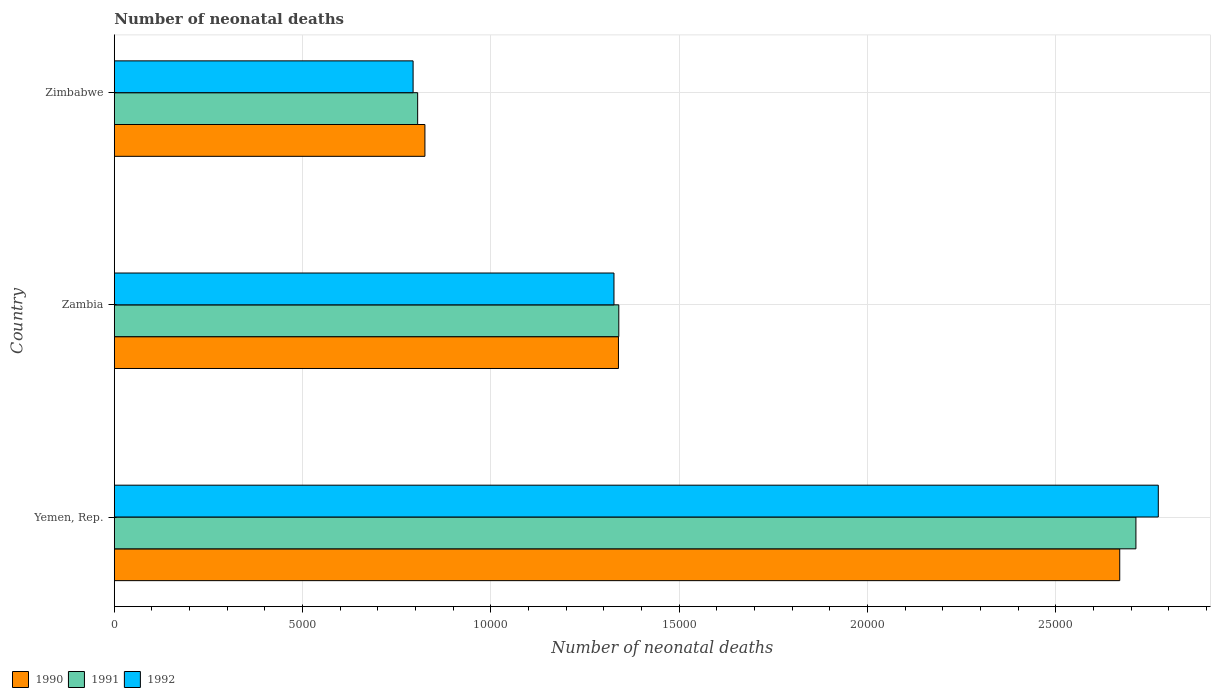How many different coloured bars are there?
Ensure brevity in your answer.  3. How many bars are there on the 1st tick from the top?
Give a very brief answer. 3. How many bars are there on the 3rd tick from the bottom?
Make the answer very short. 3. What is the label of the 2nd group of bars from the top?
Your response must be concise. Zambia. What is the number of neonatal deaths in in 1990 in Zambia?
Offer a very short reply. 1.34e+04. Across all countries, what is the maximum number of neonatal deaths in in 1990?
Make the answer very short. 2.67e+04. Across all countries, what is the minimum number of neonatal deaths in in 1990?
Offer a terse response. 8248. In which country was the number of neonatal deaths in in 1991 maximum?
Ensure brevity in your answer.  Yemen, Rep. In which country was the number of neonatal deaths in in 1992 minimum?
Ensure brevity in your answer.  Zimbabwe. What is the total number of neonatal deaths in in 1992 in the graph?
Your answer should be very brief. 4.89e+04. What is the difference between the number of neonatal deaths in in 1992 in Yemen, Rep. and that in Zambia?
Your answer should be very brief. 1.45e+04. What is the difference between the number of neonatal deaths in in 1992 in Yemen, Rep. and the number of neonatal deaths in in 1991 in Zimbabwe?
Provide a short and direct response. 1.97e+04. What is the average number of neonatal deaths in in 1990 per country?
Provide a succinct answer. 1.61e+04. What is the difference between the number of neonatal deaths in in 1991 and number of neonatal deaths in in 1990 in Zambia?
Give a very brief answer. 9. What is the ratio of the number of neonatal deaths in in 1990 in Zambia to that in Zimbabwe?
Offer a very short reply. 1.62. Is the difference between the number of neonatal deaths in in 1991 in Yemen, Rep. and Zimbabwe greater than the difference between the number of neonatal deaths in in 1990 in Yemen, Rep. and Zimbabwe?
Your answer should be compact. Yes. What is the difference between the highest and the second highest number of neonatal deaths in in 1991?
Your response must be concise. 1.37e+04. What is the difference between the highest and the lowest number of neonatal deaths in in 1992?
Keep it short and to the point. 1.98e+04. In how many countries, is the number of neonatal deaths in in 1990 greater than the average number of neonatal deaths in in 1990 taken over all countries?
Offer a terse response. 1. Is the sum of the number of neonatal deaths in in 1991 in Yemen, Rep. and Zimbabwe greater than the maximum number of neonatal deaths in in 1990 across all countries?
Provide a succinct answer. Yes. Is it the case that in every country, the sum of the number of neonatal deaths in in 1991 and number of neonatal deaths in in 1992 is greater than the number of neonatal deaths in in 1990?
Give a very brief answer. Yes. What is the difference between two consecutive major ticks on the X-axis?
Ensure brevity in your answer.  5000. Are the values on the major ticks of X-axis written in scientific E-notation?
Make the answer very short. No. What is the title of the graph?
Your answer should be compact. Number of neonatal deaths. What is the label or title of the X-axis?
Your response must be concise. Number of neonatal deaths. What is the label or title of the Y-axis?
Give a very brief answer. Country. What is the Number of neonatal deaths of 1990 in Yemen, Rep.?
Ensure brevity in your answer.  2.67e+04. What is the Number of neonatal deaths of 1991 in Yemen, Rep.?
Keep it short and to the point. 2.71e+04. What is the Number of neonatal deaths in 1992 in Yemen, Rep.?
Provide a short and direct response. 2.77e+04. What is the Number of neonatal deaths in 1990 in Zambia?
Provide a succinct answer. 1.34e+04. What is the Number of neonatal deaths of 1991 in Zambia?
Ensure brevity in your answer.  1.34e+04. What is the Number of neonatal deaths of 1992 in Zambia?
Your response must be concise. 1.33e+04. What is the Number of neonatal deaths in 1990 in Zimbabwe?
Offer a terse response. 8248. What is the Number of neonatal deaths of 1991 in Zimbabwe?
Ensure brevity in your answer.  8055. What is the Number of neonatal deaths of 1992 in Zimbabwe?
Your response must be concise. 7934. Across all countries, what is the maximum Number of neonatal deaths of 1990?
Keep it short and to the point. 2.67e+04. Across all countries, what is the maximum Number of neonatal deaths of 1991?
Your answer should be compact. 2.71e+04. Across all countries, what is the maximum Number of neonatal deaths of 1992?
Give a very brief answer. 2.77e+04. Across all countries, what is the minimum Number of neonatal deaths in 1990?
Keep it short and to the point. 8248. Across all countries, what is the minimum Number of neonatal deaths in 1991?
Provide a short and direct response. 8055. Across all countries, what is the minimum Number of neonatal deaths of 1992?
Keep it short and to the point. 7934. What is the total Number of neonatal deaths of 1990 in the graph?
Make the answer very short. 4.83e+04. What is the total Number of neonatal deaths of 1991 in the graph?
Provide a short and direct response. 4.86e+04. What is the total Number of neonatal deaths of 1992 in the graph?
Offer a terse response. 4.89e+04. What is the difference between the Number of neonatal deaths in 1990 in Yemen, Rep. and that in Zambia?
Provide a short and direct response. 1.33e+04. What is the difference between the Number of neonatal deaths of 1991 in Yemen, Rep. and that in Zambia?
Offer a terse response. 1.37e+04. What is the difference between the Number of neonatal deaths of 1992 in Yemen, Rep. and that in Zambia?
Your answer should be very brief. 1.45e+04. What is the difference between the Number of neonatal deaths in 1990 in Yemen, Rep. and that in Zimbabwe?
Ensure brevity in your answer.  1.84e+04. What is the difference between the Number of neonatal deaths of 1991 in Yemen, Rep. and that in Zimbabwe?
Offer a terse response. 1.91e+04. What is the difference between the Number of neonatal deaths in 1992 in Yemen, Rep. and that in Zimbabwe?
Give a very brief answer. 1.98e+04. What is the difference between the Number of neonatal deaths in 1990 in Zambia and that in Zimbabwe?
Provide a short and direct response. 5139. What is the difference between the Number of neonatal deaths of 1991 in Zambia and that in Zimbabwe?
Provide a short and direct response. 5341. What is the difference between the Number of neonatal deaths in 1992 in Zambia and that in Zimbabwe?
Give a very brief answer. 5334. What is the difference between the Number of neonatal deaths of 1990 in Yemen, Rep. and the Number of neonatal deaths of 1991 in Zambia?
Your response must be concise. 1.33e+04. What is the difference between the Number of neonatal deaths in 1990 in Yemen, Rep. and the Number of neonatal deaths in 1992 in Zambia?
Offer a terse response. 1.34e+04. What is the difference between the Number of neonatal deaths of 1991 in Yemen, Rep. and the Number of neonatal deaths of 1992 in Zambia?
Give a very brief answer. 1.39e+04. What is the difference between the Number of neonatal deaths of 1990 in Yemen, Rep. and the Number of neonatal deaths of 1991 in Zimbabwe?
Your answer should be compact. 1.86e+04. What is the difference between the Number of neonatal deaths in 1990 in Yemen, Rep. and the Number of neonatal deaths in 1992 in Zimbabwe?
Your answer should be compact. 1.88e+04. What is the difference between the Number of neonatal deaths of 1991 in Yemen, Rep. and the Number of neonatal deaths of 1992 in Zimbabwe?
Make the answer very short. 1.92e+04. What is the difference between the Number of neonatal deaths of 1990 in Zambia and the Number of neonatal deaths of 1991 in Zimbabwe?
Your response must be concise. 5332. What is the difference between the Number of neonatal deaths of 1990 in Zambia and the Number of neonatal deaths of 1992 in Zimbabwe?
Your answer should be compact. 5453. What is the difference between the Number of neonatal deaths of 1991 in Zambia and the Number of neonatal deaths of 1992 in Zimbabwe?
Provide a succinct answer. 5462. What is the average Number of neonatal deaths of 1990 per country?
Provide a succinct answer. 1.61e+04. What is the average Number of neonatal deaths of 1991 per country?
Your answer should be compact. 1.62e+04. What is the average Number of neonatal deaths of 1992 per country?
Offer a terse response. 1.63e+04. What is the difference between the Number of neonatal deaths in 1990 and Number of neonatal deaths in 1991 in Yemen, Rep.?
Give a very brief answer. -430. What is the difference between the Number of neonatal deaths in 1990 and Number of neonatal deaths in 1992 in Yemen, Rep.?
Offer a terse response. -1024. What is the difference between the Number of neonatal deaths in 1991 and Number of neonatal deaths in 1992 in Yemen, Rep.?
Offer a very short reply. -594. What is the difference between the Number of neonatal deaths in 1990 and Number of neonatal deaths in 1991 in Zambia?
Make the answer very short. -9. What is the difference between the Number of neonatal deaths of 1990 and Number of neonatal deaths of 1992 in Zambia?
Provide a succinct answer. 119. What is the difference between the Number of neonatal deaths of 1991 and Number of neonatal deaths of 1992 in Zambia?
Your response must be concise. 128. What is the difference between the Number of neonatal deaths in 1990 and Number of neonatal deaths in 1991 in Zimbabwe?
Ensure brevity in your answer.  193. What is the difference between the Number of neonatal deaths in 1990 and Number of neonatal deaths in 1992 in Zimbabwe?
Ensure brevity in your answer.  314. What is the difference between the Number of neonatal deaths of 1991 and Number of neonatal deaths of 1992 in Zimbabwe?
Keep it short and to the point. 121. What is the ratio of the Number of neonatal deaths of 1990 in Yemen, Rep. to that in Zambia?
Your response must be concise. 1.99. What is the ratio of the Number of neonatal deaths of 1991 in Yemen, Rep. to that in Zambia?
Make the answer very short. 2.03. What is the ratio of the Number of neonatal deaths of 1992 in Yemen, Rep. to that in Zambia?
Make the answer very short. 2.09. What is the ratio of the Number of neonatal deaths of 1990 in Yemen, Rep. to that in Zimbabwe?
Provide a succinct answer. 3.24. What is the ratio of the Number of neonatal deaths of 1991 in Yemen, Rep. to that in Zimbabwe?
Offer a terse response. 3.37. What is the ratio of the Number of neonatal deaths in 1992 in Yemen, Rep. to that in Zimbabwe?
Keep it short and to the point. 3.49. What is the ratio of the Number of neonatal deaths in 1990 in Zambia to that in Zimbabwe?
Keep it short and to the point. 1.62. What is the ratio of the Number of neonatal deaths of 1991 in Zambia to that in Zimbabwe?
Ensure brevity in your answer.  1.66. What is the ratio of the Number of neonatal deaths in 1992 in Zambia to that in Zimbabwe?
Ensure brevity in your answer.  1.67. What is the difference between the highest and the second highest Number of neonatal deaths in 1990?
Provide a short and direct response. 1.33e+04. What is the difference between the highest and the second highest Number of neonatal deaths in 1991?
Keep it short and to the point. 1.37e+04. What is the difference between the highest and the second highest Number of neonatal deaths of 1992?
Offer a very short reply. 1.45e+04. What is the difference between the highest and the lowest Number of neonatal deaths in 1990?
Your response must be concise. 1.84e+04. What is the difference between the highest and the lowest Number of neonatal deaths of 1991?
Make the answer very short. 1.91e+04. What is the difference between the highest and the lowest Number of neonatal deaths in 1992?
Make the answer very short. 1.98e+04. 